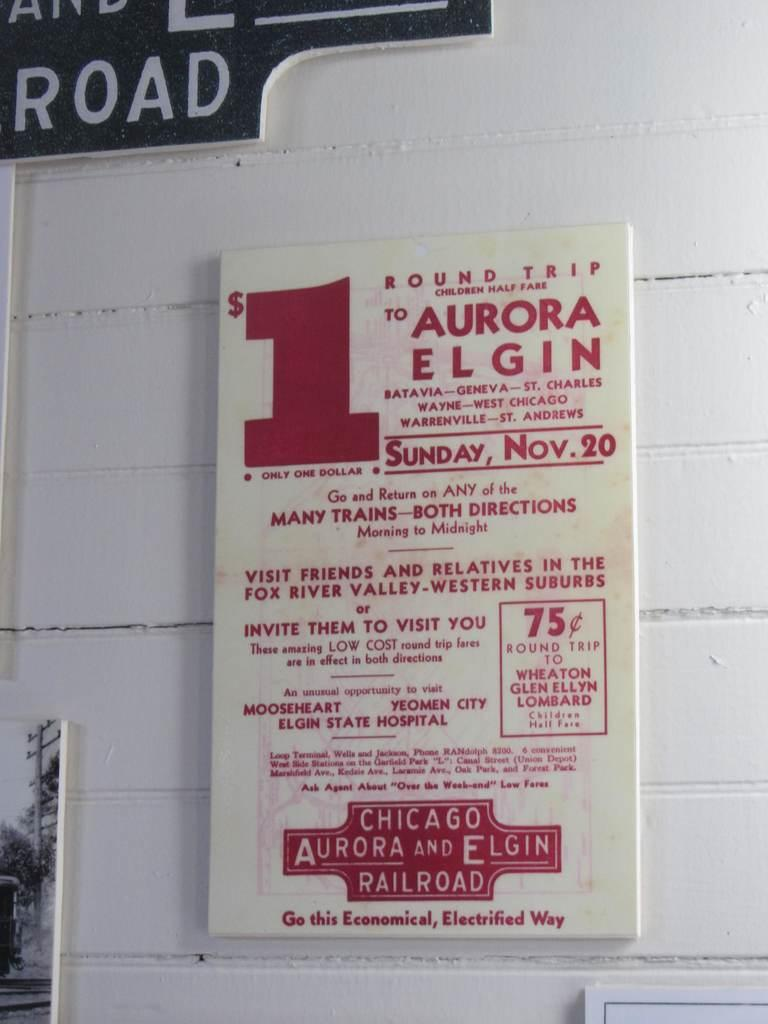<image>
Describe the image concisely. a paper ad stating $ 1 to aurora elgin 